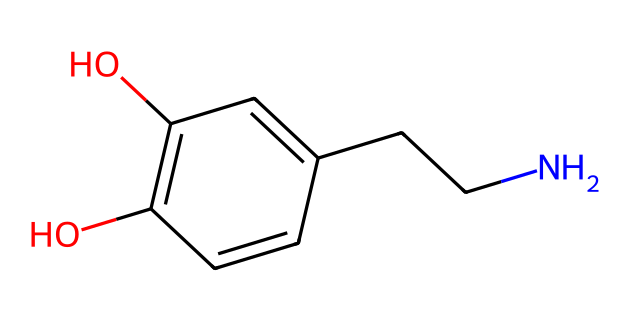What is the molecular formula of this compound? To find the molecular formula, we need to count the number of each type of atom in the SMILES representation. The structure reveals: 9 carbons (C), 13 hydrogens (H), 1 nitrogen (N), and 2 oxygens (O). Therefore, the molecular formula is C9H13NO2.
Answer: C9H13NO2 How many hydroxyl (–OH) groups are present in the structure? The SMILES representation indicates two “O”s that are directly attached to carbon, which represent hydroxyl groups. Thus, there are two hydroxyl groups present in the compound.
Answer: 2 What type of functional groups are present in this molecule? Analyzing the chemical structure, we observe that it has hydroxyl groups (–OH) as well as an amine group (–NH). Thus, the key functional groups are alcohol and amine.
Answer: alcohol and amine Which atom is responsible for the molecule's ability to form hydrogen bonds? The presence of hydroxyl (–OH) groups indicates that the oxygen atom is involved in forming hydrogen bonds due to its electronegativity and lone pairs, making it the key atom for hydrogen bonding.
Answer: oxygen What distinguishes this compound from typical aldehydes? Aldehydes usually have a carbonyl group (C=O) at the terminal position, whereas this compound has a more complex structure with multiple functional groups, meaning it does not have the typical aldehydic structure despite its derivation from phenethylamine.
Answer: complex structure How many rings are present in the compound? The structure does not show any closed loops or cyclic arrangements but contains a linear and branched structure produced by a phenolic compound. Hence, there are zero rings present.
Answer: 0 